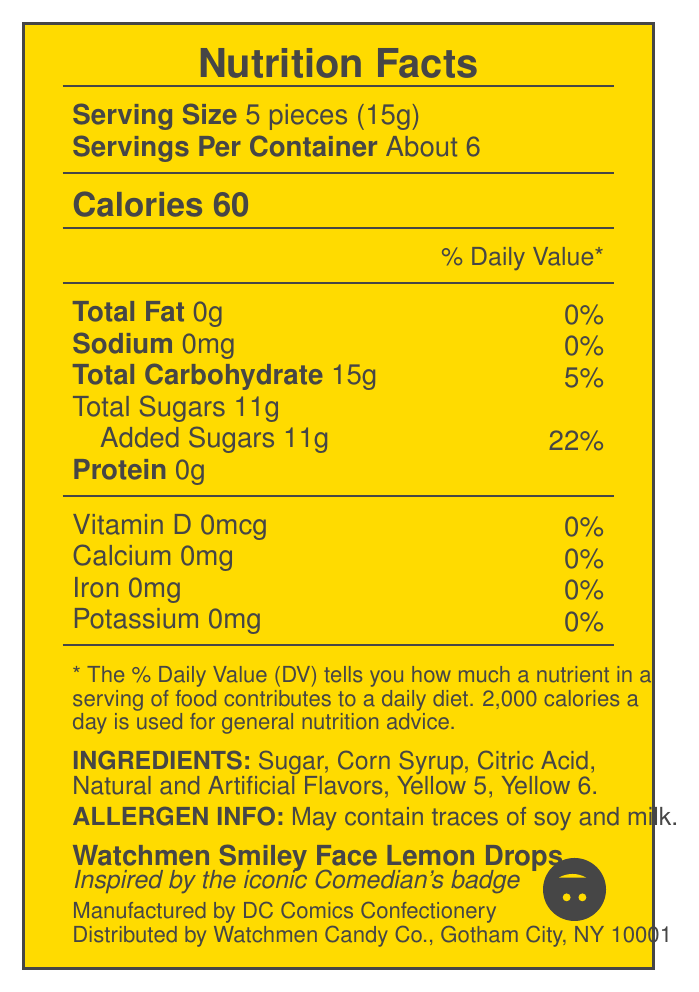what is the serving size of Watchmen Smiley Face Lemon Drops? The document states the serving size as "5 pieces (15g)" under the serving information section.
Answer: 5 pieces (15g) how many calories are in one serving of Watchmen Smiley Face Lemon Drops? The calories are listed as 60 under the calories section on the document.
Answer: 60 calories what is the total carbohydrate content per serving? The total carbohydrate content is mentioned as 15g in the nutrients section of the document.
Answer: 15g does the product contain any protein? The document states that the protein content is 0g per serving.
Answer: No is there any sodium in Watchmen Smiley Face Lemon Drops? Sodium content is listed as 0mg, thus indicating there is no sodium in this product.
Answer: No what are the first two ingredients listed? The ingredients section lists the first two ingredients as "Sugar" and "Corn Syrup".
Answer: Sugar, Corn Syrup how many servings are in one container of Watchmen Smiley Face Lemon Drops? The document states that each container has about 6 servings.
Answer: About 6 what is the amount of added sugars in one serving? A. 11g B. 9g C. 5g D. 15g The document lists "Added Sugars 11g" under the nutrients section, making A the correct option.
Answer: A who manufactures Watchmen Smiley Face Lemon Drops? A. Watchmen Candy Co. B. Gotham City Sweets C. DC Comics Confectionery D. Alan Moore Confectionery The manufacturer is stated as DC Comics Confectionery in the document.
Answer: C can you find iron content in this product? A. Yes B. No Under the vitamins and minerals section, iron is listed as 0mg, indicating no iron content.
Answer: B is there any allergen information provided? The document mentions under the allergen info section that the product "May contain traces of soy and milk."
Answer: Yes is the product available in general grocery stores? The document states that the product is "Available only at comic book shops and specialty stores."
Answer: No describe the document The document is laid out visually, including a bright color scheme that aligns with the comic book theme.
Answer: The document is a detailed Nutrition Facts label for "Watchmen Smiley Face Lemon Drops," a themed candy based on Alan Moore's "Watchmen" series. It contains information about serving size, servings per container, calorie content, and various nutrients. Additionally, the document includes ingredient and allergen information, manufacturer and distributor details, and special notes about the product's comic tie-in, collectible packaging, and retailer exclusivity. what is the exact Pantone shade of yellow used for the smiley face in the original comic? The document mentions the trivia about the yellow color matching the Pantone shade used in the comic but does not specify the exact Pantone shade.
Answer: Cannot be determined 